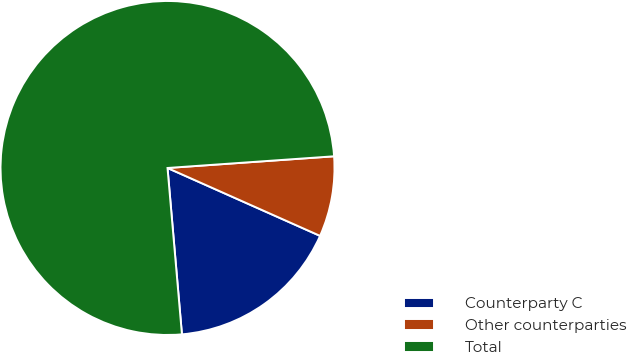<chart> <loc_0><loc_0><loc_500><loc_500><pie_chart><fcel>Counterparty C<fcel>Other counterparties<fcel>Total<nl><fcel>16.96%<fcel>7.78%<fcel>75.26%<nl></chart> 